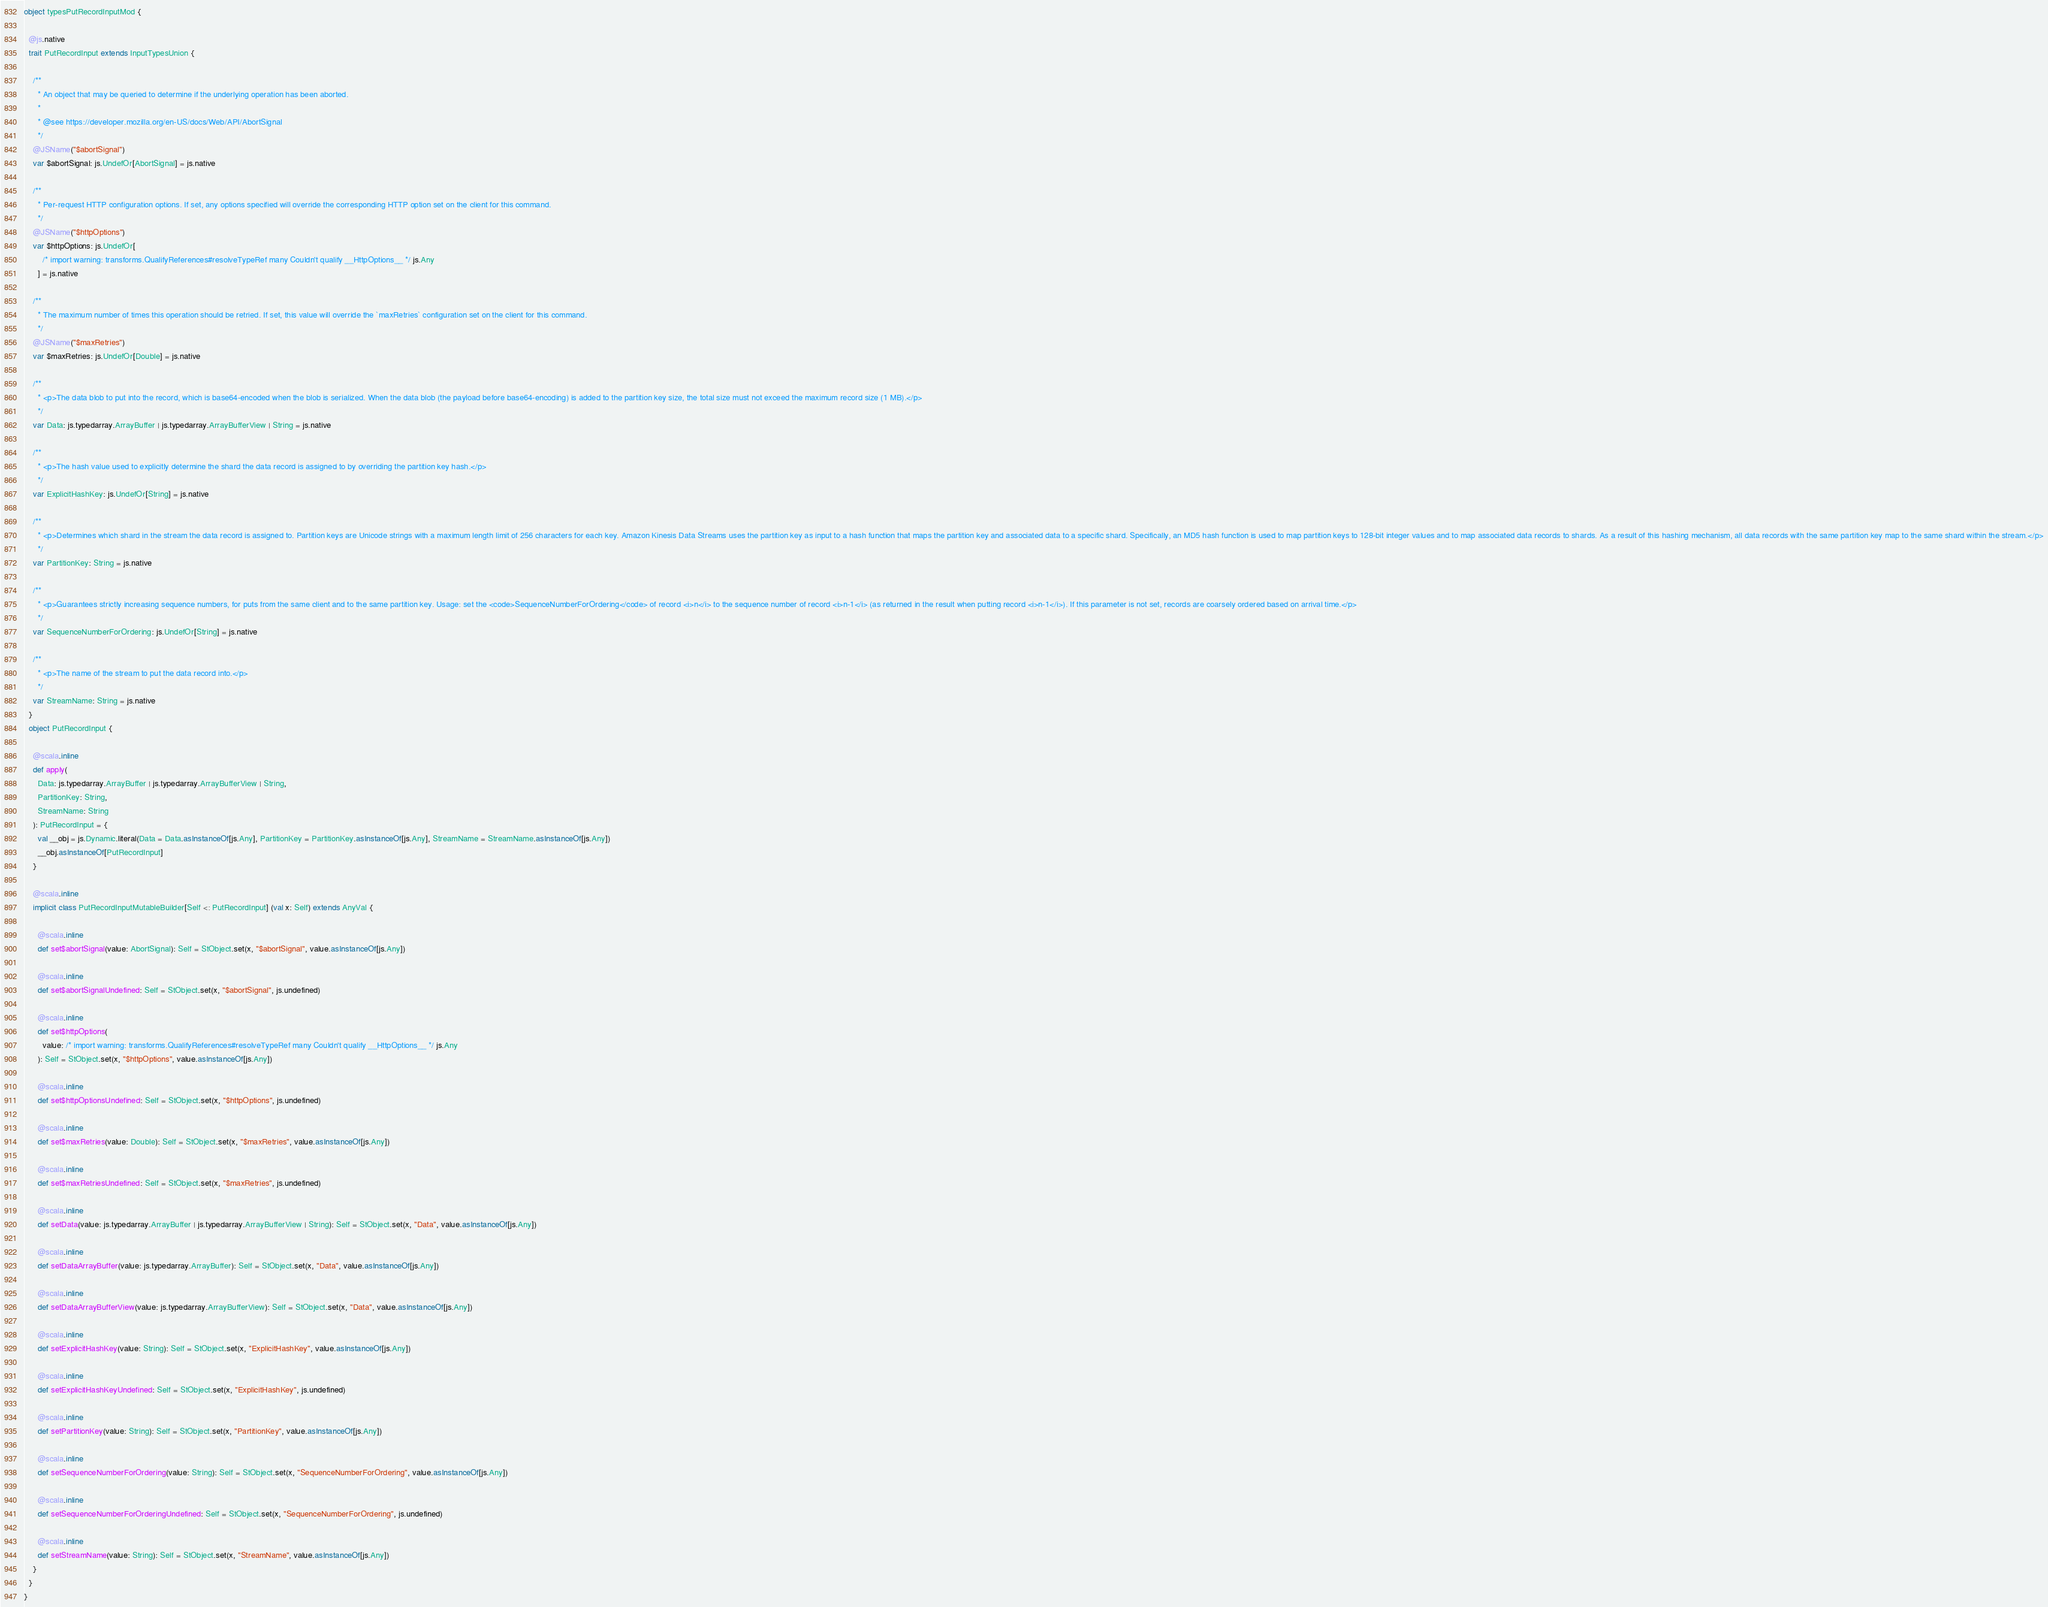<code> <loc_0><loc_0><loc_500><loc_500><_Scala_>
object typesPutRecordInputMod {
  
  @js.native
  trait PutRecordInput extends InputTypesUnion {
    
    /**
      * An object that may be queried to determine if the underlying operation has been aborted.
      *
      * @see https://developer.mozilla.org/en-US/docs/Web/API/AbortSignal
      */
    @JSName("$abortSignal")
    var $abortSignal: js.UndefOr[AbortSignal] = js.native
    
    /**
      * Per-request HTTP configuration options. If set, any options specified will override the corresponding HTTP option set on the client for this command.
      */
    @JSName("$httpOptions")
    var $httpOptions: js.UndefOr[
        /* import warning: transforms.QualifyReferences#resolveTypeRef many Couldn't qualify __HttpOptions__ */ js.Any
      ] = js.native
    
    /**
      * The maximum number of times this operation should be retried. If set, this value will override the `maxRetries` configuration set on the client for this command.
      */
    @JSName("$maxRetries")
    var $maxRetries: js.UndefOr[Double] = js.native
    
    /**
      * <p>The data blob to put into the record, which is base64-encoded when the blob is serialized. When the data blob (the payload before base64-encoding) is added to the partition key size, the total size must not exceed the maximum record size (1 MB).</p>
      */
    var Data: js.typedarray.ArrayBuffer | js.typedarray.ArrayBufferView | String = js.native
    
    /**
      * <p>The hash value used to explicitly determine the shard the data record is assigned to by overriding the partition key hash.</p>
      */
    var ExplicitHashKey: js.UndefOr[String] = js.native
    
    /**
      * <p>Determines which shard in the stream the data record is assigned to. Partition keys are Unicode strings with a maximum length limit of 256 characters for each key. Amazon Kinesis Data Streams uses the partition key as input to a hash function that maps the partition key and associated data to a specific shard. Specifically, an MD5 hash function is used to map partition keys to 128-bit integer values and to map associated data records to shards. As a result of this hashing mechanism, all data records with the same partition key map to the same shard within the stream.</p>
      */
    var PartitionKey: String = js.native
    
    /**
      * <p>Guarantees strictly increasing sequence numbers, for puts from the same client and to the same partition key. Usage: set the <code>SequenceNumberForOrdering</code> of record <i>n</i> to the sequence number of record <i>n-1</i> (as returned in the result when putting record <i>n-1</i>). If this parameter is not set, records are coarsely ordered based on arrival time.</p>
      */
    var SequenceNumberForOrdering: js.UndefOr[String] = js.native
    
    /**
      * <p>The name of the stream to put the data record into.</p>
      */
    var StreamName: String = js.native
  }
  object PutRecordInput {
    
    @scala.inline
    def apply(
      Data: js.typedarray.ArrayBuffer | js.typedarray.ArrayBufferView | String,
      PartitionKey: String,
      StreamName: String
    ): PutRecordInput = {
      val __obj = js.Dynamic.literal(Data = Data.asInstanceOf[js.Any], PartitionKey = PartitionKey.asInstanceOf[js.Any], StreamName = StreamName.asInstanceOf[js.Any])
      __obj.asInstanceOf[PutRecordInput]
    }
    
    @scala.inline
    implicit class PutRecordInputMutableBuilder[Self <: PutRecordInput] (val x: Self) extends AnyVal {
      
      @scala.inline
      def set$abortSignal(value: AbortSignal): Self = StObject.set(x, "$abortSignal", value.asInstanceOf[js.Any])
      
      @scala.inline
      def set$abortSignalUndefined: Self = StObject.set(x, "$abortSignal", js.undefined)
      
      @scala.inline
      def set$httpOptions(
        value: /* import warning: transforms.QualifyReferences#resolveTypeRef many Couldn't qualify __HttpOptions__ */ js.Any
      ): Self = StObject.set(x, "$httpOptions", value.asInstanceOf[js.Any])
      
      @scala.inline
      def set$httpOptionsUndefined: Self = StObject.set(x, "$httpOptions", js.undefined)
      
      @scala.inline
      def set$maxRetries(value: Double): Self = StObject.set(x, "$maxRetries", value.asInstanceOf[js.Any])
      
      @scala.inline
      def set$maxRetriesUndefined: Self = StObject.set(x, "$maxRetries", js.undefined)
      
      @scala.inline
      def setData(value: js.typedarray.ArrayBuffer | js.typedarray.ArrayBufferView | String): Self = StObject.set(x, "Data", value.asInstanceOf[js.Any])
      
      @scala.inline
      def setDataArrayBuffer(value: js.typedarray.ArrayBuffer): Self = StObject.set(x, "Data", value.asInstanceOf[js.Any])
      
      @scala.inline
      def setDataArrayBufferView(value: js.typedarray.ArrayBufferView): Self = StObject.set(x, "Data", value.asInstanceOf[js.Any])
      
      @scala.inline
      def setExplicitHashKey(value: String): Self = StObject.set(x, "ExplicitHashKey", value.asInstanceOf[js.Any])
      
      @scala.inline
      def setExplicitHashKeyUndefined: Self = StObject.set(x, "ExplicitHashKey", js.undefined)
      
      @scala.inline
      def setPartitionKey(value: String): Self = StObject.set(x, "PartitionKey", value.asInstanceOf[js.Any])
      
      @scala.inline
      def setSequenceNumberForOrdering(value: String): Self = StObject.set(x, "SequenceNumberForOrdering", value.asInstanceOf[js.Any])
      
      @scala.inline
      def setSequenceNumberForOrderingUndefined: Self = StObject.set(x, "SequenceNumberForOrdering", js.undefined)
      
      @scala.inline
      def setStreamName(value: String): Self = StObject.set(x, "StreamName", value.asInstanceOf[js.Any])
    }
  }
}
</code> 